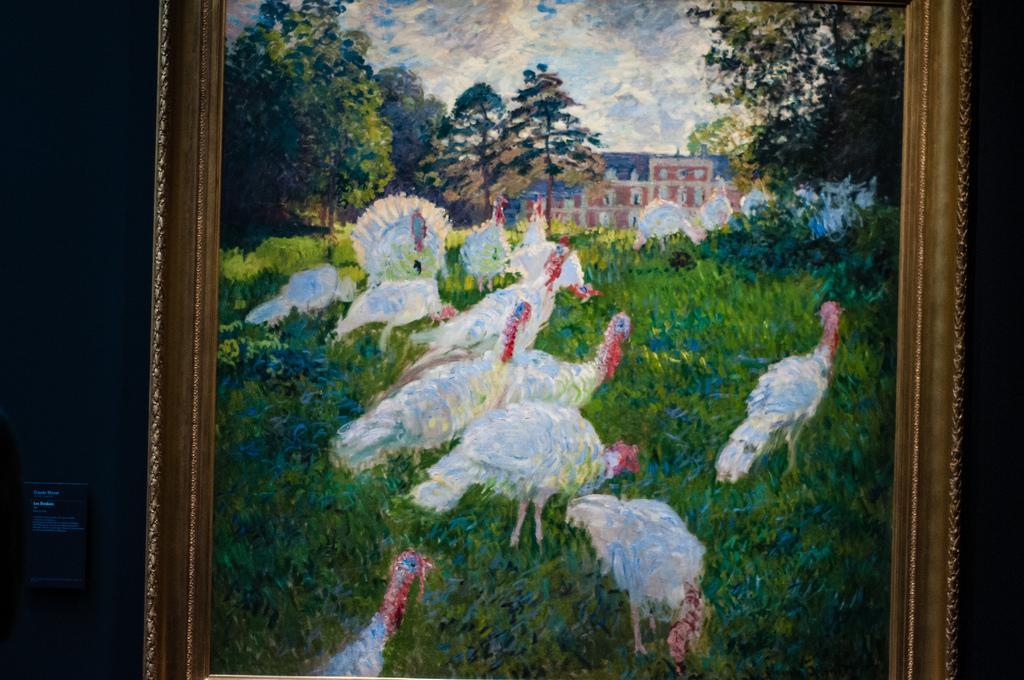How would you summarize this image in a sentence or two? This picture consists of a portrait in the image, in which there are hens on the grassland, trees, and a building. 